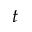<formula> <loc_0><loc_0><loc_500><loc_500>t</formula> 